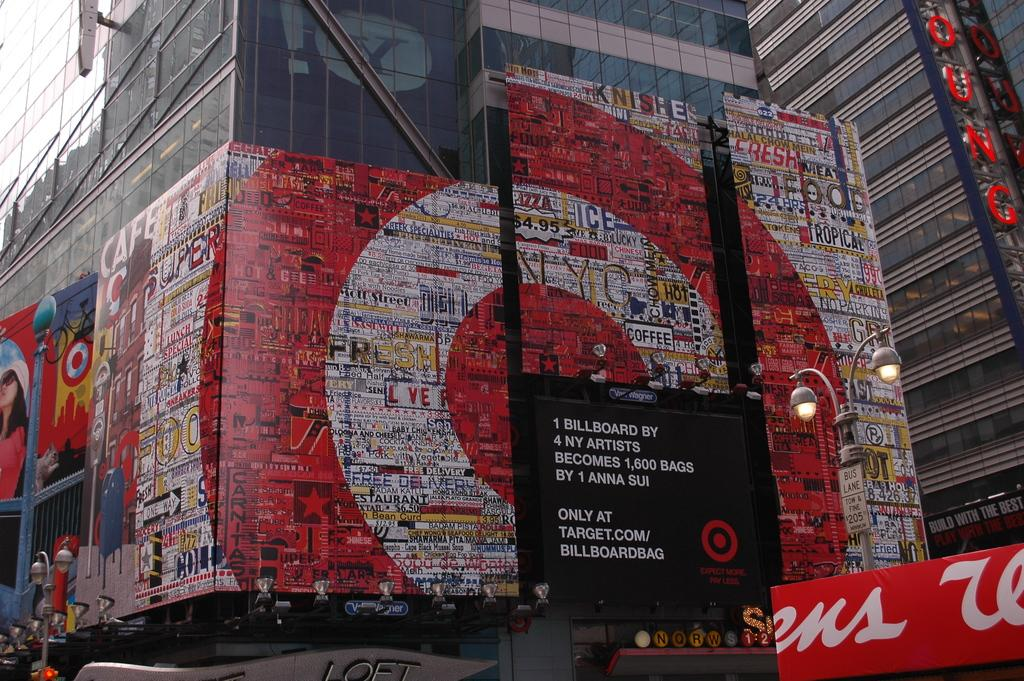<image>
Provide a brief description of the given image. a mostlly red and white billboard on a building featuring target.com 